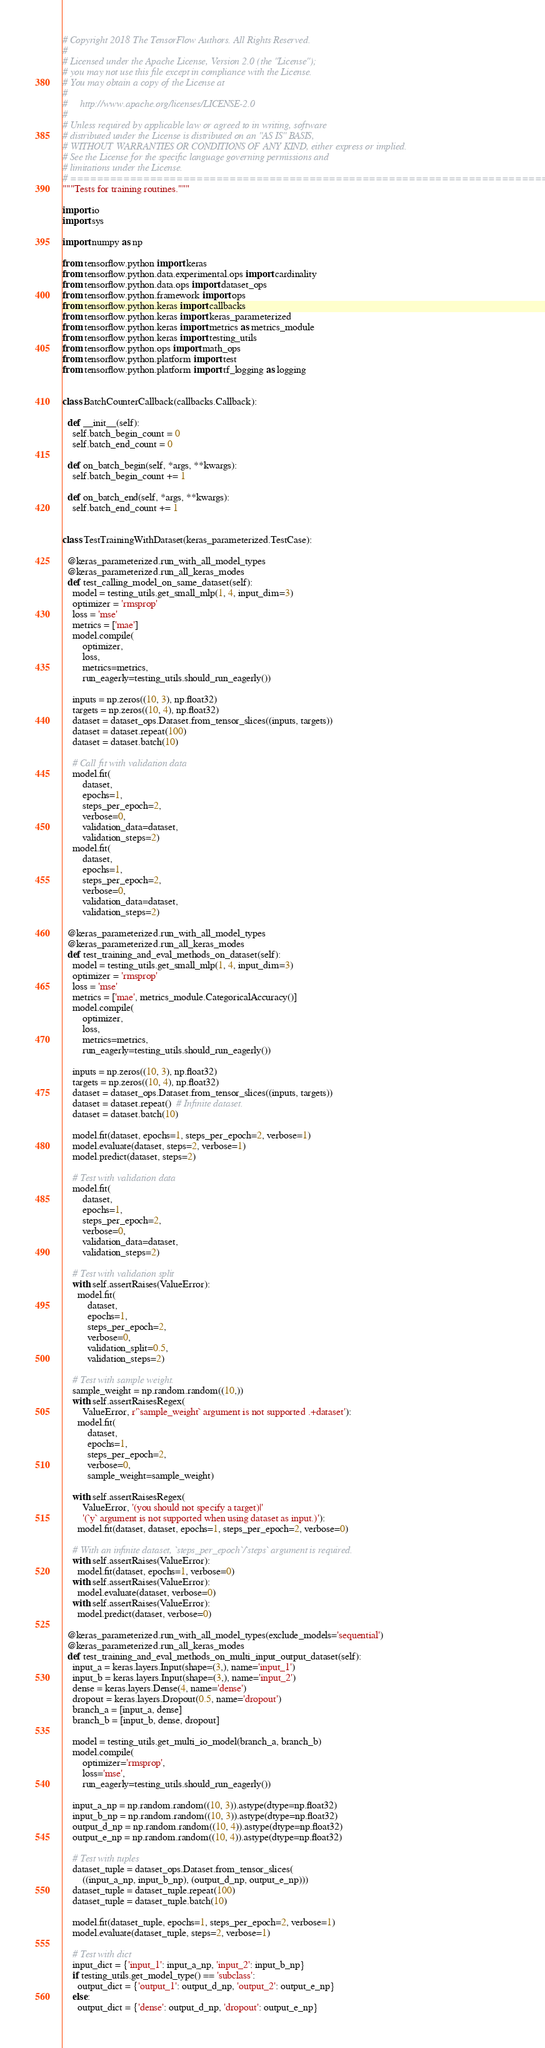Convert code to text. <code><loc_0><loc_0><loc_500><loc_500><_Python_># Copyright 2018 The TensorFlow Authors. All Rights Reserved.
#
# Licensed under the Apache License, Version 2.0 (the "License");
# you may not use this file except in compliance with the License.
# You may obtain a copy of the License at
#
#     http://www.apache.org/licenses/LICENSE-2.0
#
# Unless required by applicable law or agreed to in writing, software
# distributed under the License is distributed on an "AS IS" BASIS,
# WITHOUT WARRANTIES OR CONDITIONS OF ANY KIND, either express or implied.
# See the License for the specific language governing permissions and
# limitations under the License.
# ==============================================================================
"""Tests for training routines."""

import io
import sys

import numpy as np

from tensorflow.python import keras
from tensorflow.python.data.experimental.ops import cardinality
from tensorflow.python.data.ops import dataset_ops
from tensorflow.python.framework import ops
from tensorflow.python.keras import callbacks
from tensorflow.python.keras import keras_parameterized
from tensorflow.python.keras import metrics as metrics_module
from tensorflow.python.keras import testing_utils
from tensorflow.python.ops import math_ops
from tensorflow.python.platform import test
from tensorflow.python.platform import tf_logging as logging


class BatchCounterCallback(callbacks.Callback):

  def __init__(self):
    self.batch_begin_count = 0
    self.batch_end_count = 0

  def on_batch_begin(self, *args, **kwargs):
    self.batch_begin_count += 1

  def on_batch_end(self, *args, **kwargs):
    self.batch_end_count += 1


class TestTrainingWithDataset(keras_parameterized.TestCase):

  @keras_parameterized.run_with_all_model_types
  @keras_parameterized.run_all_keras_modes
  def test_calling_model_on_same_dataset(self):
    model = testing_utils.get_small_mlp(1, 4, input_dim=3)
    optimizer = 'rmsprop'
    loss = 'mse'
    metrics = ['mae']
    model.compile(
        optimizer,
        loss,
        metrics=metrics,
        run_eagerly=testing_utils.should_run_eagerly())

    inputs = np.zeros((10, 3), np.float32)
    targets = np.zeros((10, 4), np.float32)
    dataset = dataset_ops.Dataset.from_tensor_slices((inputs, targets))
    dataset = dataset.repeat(100)
    dataset = dataset.batch(10)

    # Call fit with validation data
    model.fit(
        dataset,
        epochs=1,
        steps_per_epoch=2,
        verbose=0,
        validation_data=dataset,
        validation_steps=2)
    model.fit(
        dataset,
        epochs=1,
        steps_per_epoch=2,
        verbose=0,
        validation_data=dataset,
        validation_steps=2)

  @keras_parameterized.run_with_all_model_types
  @keras_parameterized.run_all_keras_modes
  def test_training_and_eval_methods_on_dataset(self):
    model = testing_utils.get_small_mlp(1, 4, input_dim=3)
    optimizer = 'rmsprop'
    loss = 'mse'
    metrics = ['mae', metrics_module.CategoricalAccuracy()]
    model.compile(
        optimizer,
        loss,
        metrics=metrics,
        run_eagerly=testing_utils.should_run_eagerly())

    inputs = np.zeros((10, 3), np.float32)
    targets = np.zeros((10, 4), np.float32)
    dataset = dataset_ops.Dataset.from_tensor_slices((inputs, targets))
    dataset = dataset.repeat()  # Infinite dataset.
    dataset = dataset.batch(10)

    model.fit(dataset, epochs=1, steps_per_epoch=2, verbose=1)
    model.evaluate(dataset, steps=2, verbose=1)
    model.predict(dataset, steps=2)

    # Test with validation data
    model.fit(
        dataset,
        epochs=1,
        steps_per_epoch=2,
        verbose=0,
        validation_data=dataset,
        validation_steps=2)

    # Test with validation split
    with self.assertRaises(ValueError):
      model.fit(
          dataset,
          epochs=1,
          steps_per_epoch=2,
          verbose=0,
          validation_split=0.5,
          validation_steps=2)

    # Test with sample weight.
    sample_weight = np.random.random((10,))
    with self.assertRaisesRegex(
        ValueError, r'`sample_weight` argument is not supported .+dataset'):
      model.fit(
          dataset,
          epochs=1,
          steps_per_epoch=2,
          verbose=0,
          sample_weight=sample_weight)

    with self.assertRaisesRegex(
        ValueError, '(you should not specify a target)|'
        '(`y` argument is not supported when using dataset as input.)'):
      model.fit(dataset, dataset, epochs=1, steps_per_epoch=2, verbose=0)

    # With an infinite dataset, `steps_per_epoch`/`steps` argument is required.
    with self.assertRaises(ValueError):
      model.fit(dataset, epochs=1, verbose=0)
    with self.assertRaises(ValueError):
      model.evaluate(dataset, verbose=0)
    with self.assertRaises(ValueError):
      model.predict(dataset, verbose=0)

  @keras_parameterized.run_with_all_model_types(exclude_models='sequential')
  @keras_parameterized.run_all_keras_modes
  def test_training_and_eval_methods_on_multi_input_output_dataset(self):
    input_a = keras.layers.Input(shape=(3,), name='input_1')
    input_b = keras.layers.Input(shape=(3,), name='input_2')
    dense = keras.layers.Dense(4, name='dense')
    dropout = keras.layers.Dropout(0.5, name='dropout')
    branch_a = [input_a, dense]
    branch_b = [input_b, dense, dropout]

    model = testing_utils.get_multi_io_model(branch_a, branch_b)
    model.compile(
        optimizer='rmsprop',
        loss='mse',
        run_eagerly=testing_utils.should_run_eagerly())

    input_a_np = np.random.random((10, 3)).astype(dtype=np.float32)
    input_b_np = np.random.random((10, 3)).astype(dtype=np.float32)
    output_d_np = np.random.random((10, 4)).astype(dtype=np.float32)
    output_e_np = np.random.random((10, 4)).astype(dtype=np.float32)

    # Test with tuples
    dataset_tuple = dataset_ops.Dataset.from_tensor_slices(
        ((input_a_np, input_b_np), (output_d_np, output_e_np)))
    dataset_tuple = dataset_tuple.repeat(100)
    dataset_tuple = dataset_tuple.batch(10)

    model.fit(dataset_tuple, epochs=1, steps_per_epoch=2, verbose=1)
    model.evaluate(dataset_tuple, steps=2, verbose=1)

    # Test with dict
    input_dict = {'input_1': input_a_np, 'input_2': input_b_np}
    if testing_utils.get_model_type() == 'subclass':
      output_dict = {'output_1': output_d_np, 'output_2': output_e_np}
    else:
      output_dict = {'dense': output_d_np, 'dropout': output_e_np}
</code> 